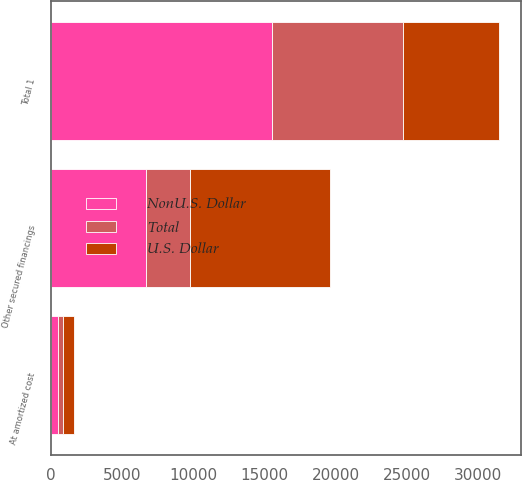Convert chart to OTSL. <chart><loc_0><loc_0><loc_500><loc_500><stacked_bar_chart><ecel><fcel>Other secured financings<fcel>At amortized cost<fcel>Total 1<nl><fcel>NonU.S. Dollar<fcel>6702<fcel>514<fcel>15538<nl><fcel>Total<fcel>3105<fcel>319<fcel>9215<nl><fcel>U.S. Dollar<fcel>9807<fcel>833<fcel>6702<nl></chart> 